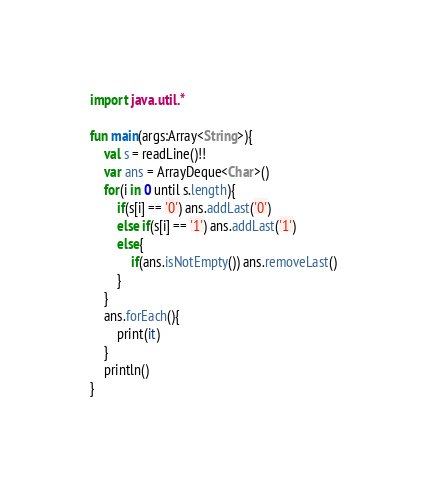Convert code to text. <code><loc_0><loc_0><loc_500><loc_500><_Kotlin_>import java.util.*

fun main(args:Array<String>){
    val s = readLine()!!
    var ans = ArrayDeque<Char>()
    for(i in 0 until s.length){
        if(s[i] == '0') ans.addLast('0')
        else if(s[i] == '1') ans.addLast('1')
        else{
            if(ans.isNotEmpty()) ans.removeLast()
        }
    }
    ans.forEach(){
        print(it)
    }
    println()
}
</code> 